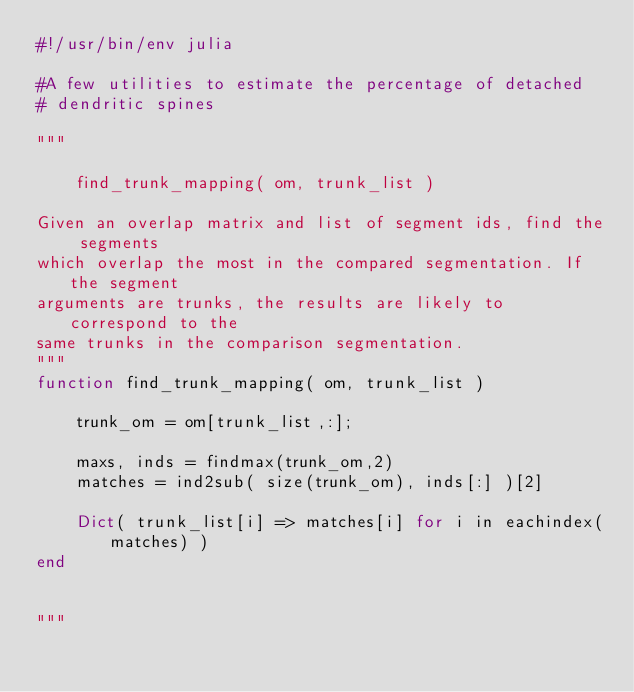Convert code to text. <code><loc_0><loc_0><loc_500><loc_500><_Julia_>#!/usr/bin/env julia

#A few utilities to estimate the percentage of detached
# dendritic spines

"""

    find_trunk_mapping( om, trunk_list )

Given an overlap matrix and list of segment ids, find the segments
which overlap the most in the compared segmentation. If the segment
arguments are trunks, the results are likely to correspond to the
same trunks in the comparison segmentation.
"""
function find_trunk_mapping( om, trunk_list )

    trunk_om = om[trunk_list,:];

    maxs, inds = findmax(trunk_om,2)
    matches = ind2sub( size(trunk_om), inds[:] )[2]

    Dict( trunk_list[i] => matches[i] for i in eachindex(matches) )
end


"""
</code> 